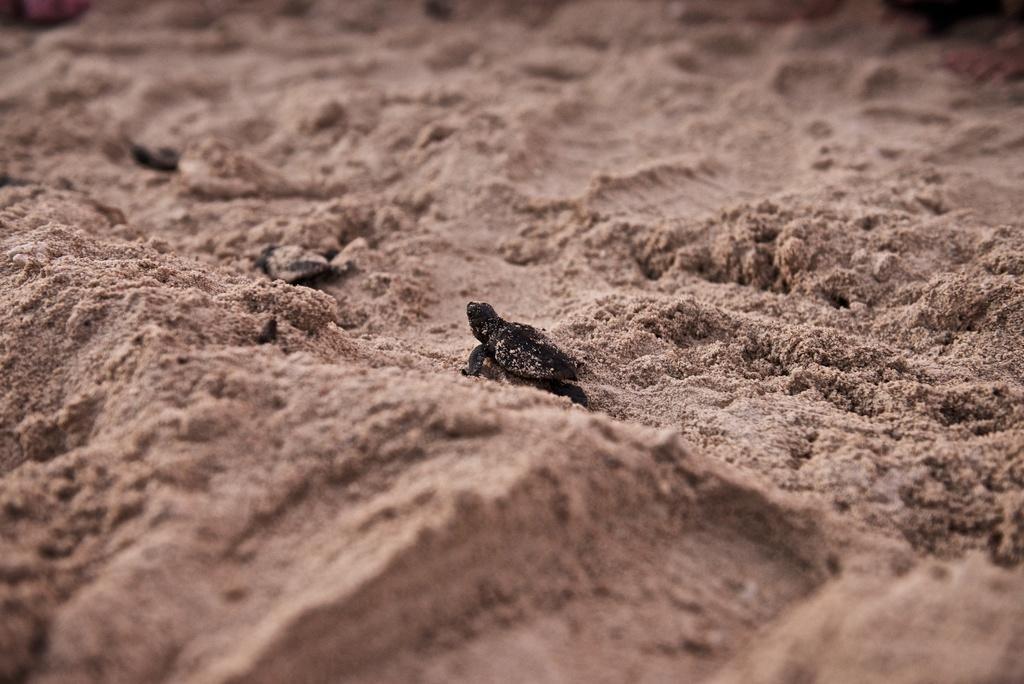In one or two sentences, can you explain what this image depicts? In this image in the center there are turtles on the sand. 